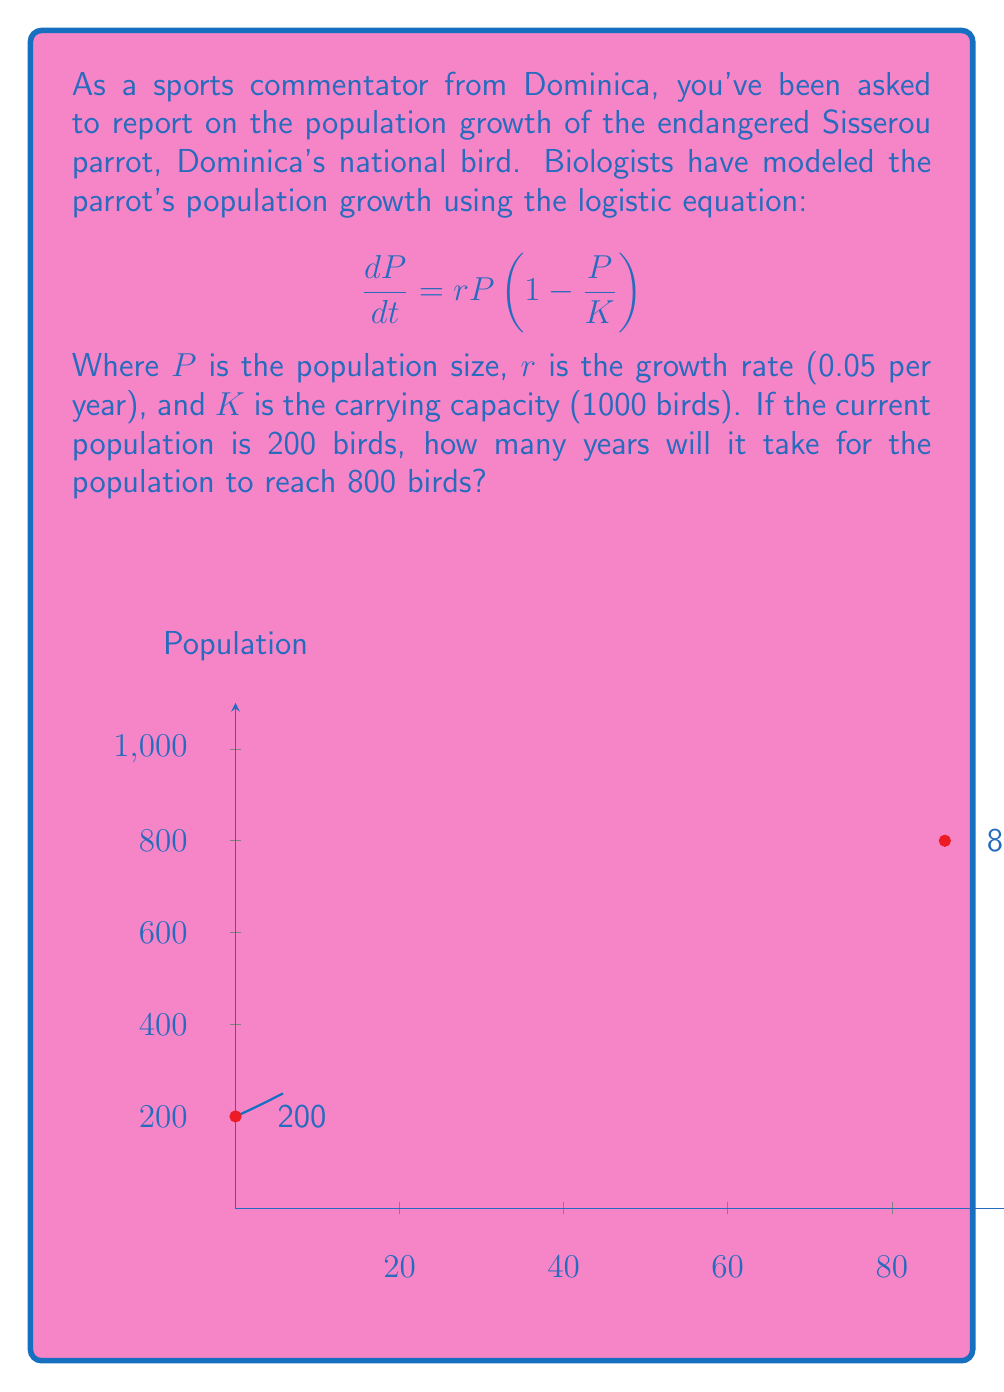Can you answer this question? To solve this problem, we'll use the analytical solution of the logistic equation:

$$P(t) = \frac{K}{1 + (\frac{K}{P_0} - 1)e^{-rt}}$$

Where $P_0$ is the initial population.

Step 1: Substitute the known values into the equation:
$$800 = \frac{1000}{1 + (\frac{1000}{200} - 1)e^{-0.05t}}$$

Step 2: Simplify:
$$800 = \frac{1000}{1 + 4e^{-0.05t}}$$

Step 3: Multiply both sides by $(1 + 4e^{-0.05t})$:
$$800(1 + 4e^{-0.05t}) = 1000$$

Step 4: Distribute:
$$800 + 3200e^{-0.05t} = 1000$$

Step 5: Subtract 800 from both sides:
$$3200e^{-0.05t} = 200$$

Step 6: Divide both sides by 3200:
$$e^{-0.05t} = \frac{1}{16}$$

Step 7: Take the natural log of both sides:
$$-0.05t = \ln(\frac{1}{16})$$

Step 8: Solve for t:
$$t = \frac{-\ln(\frac{1}{16})}{0.05} = \frac{\ln(16)}{0.05} \approx 86.47$$

Therefore, it will take approximately 86.47 years for the population to reach 800 birds.
Answer: 86.47 years 